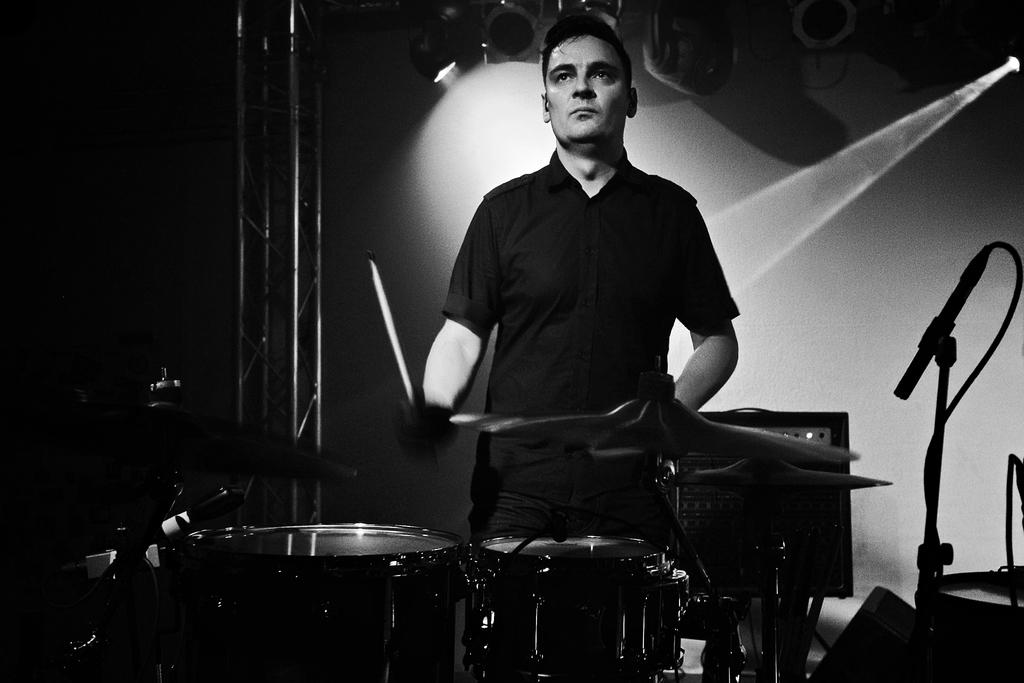What is the main subject of the image? The main subject of the image is a man. What is the man doing in the image? The man is standing and playing drums in the image. Where are the drums located in the image? The drums are on a dais in the image. Can you describe the position of the microphone in the image? The microphone is on the right side of the image. How many goldfish can be seen swimming in the image? There are no goldfish present in the image. What type of airplane is visible in the image? There is no airplane visible in the image. 